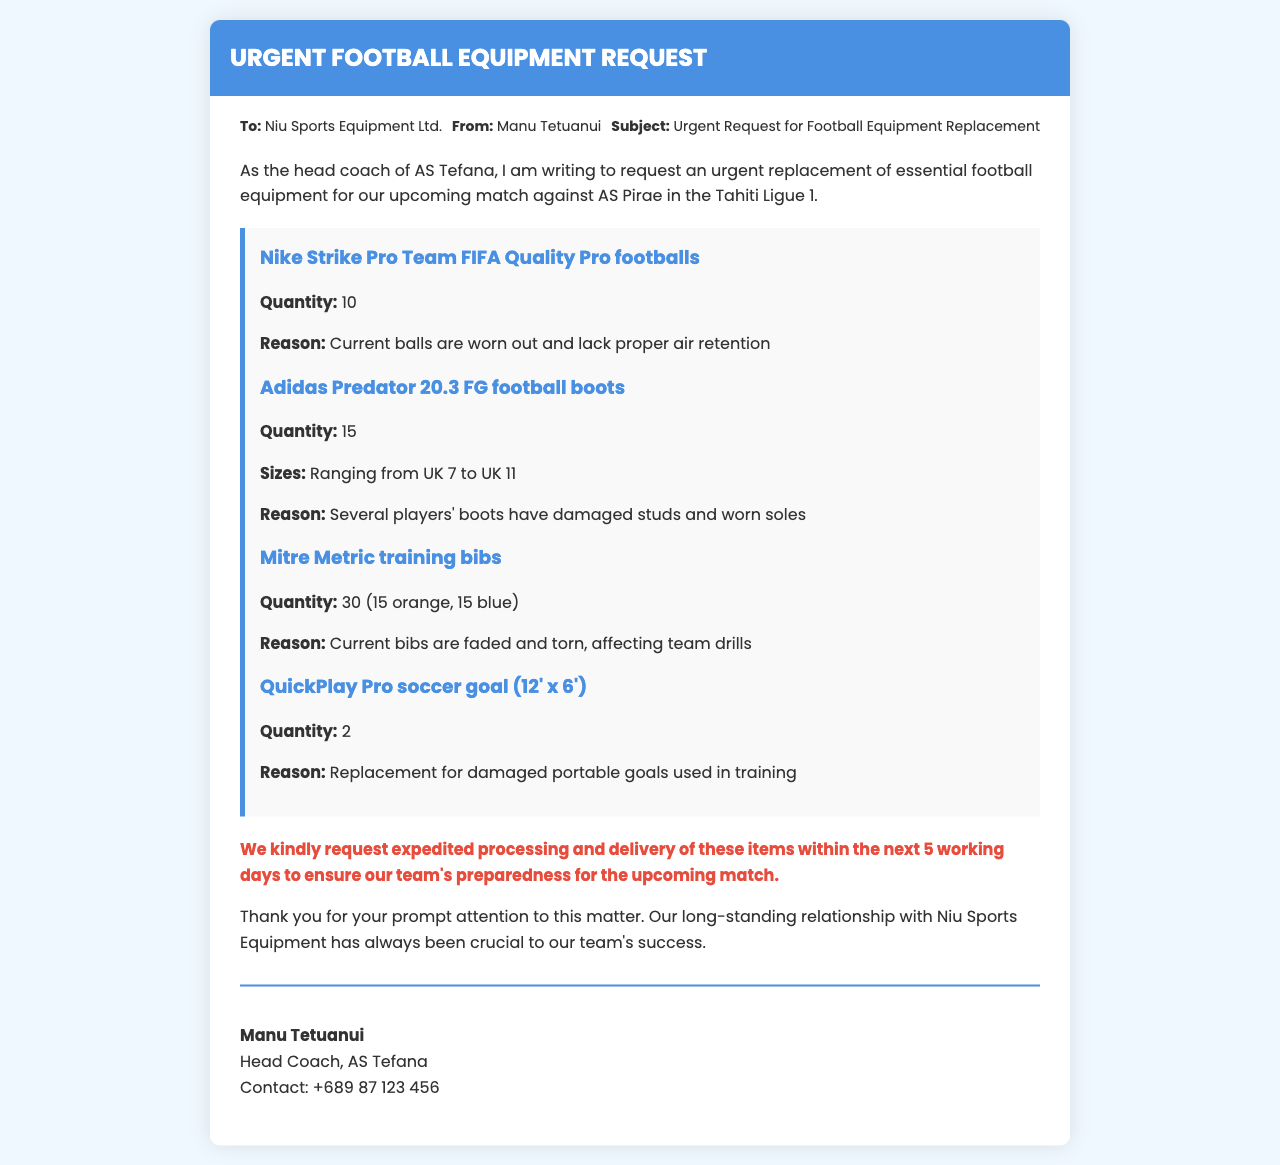what is the subject of the fax? The subject is mentioned in the meta section of the fax and is "Urgent Request for Football Equipment Replacement."
Answer: Urgent Request for Football Equipment Replacement who is the sender of the document? The sender's name is provided in the meta section, which states "From: Manu Tetuanui."
Answer: Manu Tetuanui how many footballs are being requested? The quantity of footballs needed is specified in the equipment list as "10."
Answer: 10 what is the reason for requesting new training bibs? The document states the reason in relation to the bibs: "Current bibs are faded and torn, affecting team drills."
Answer: Faded and torn what contact information is provided for the sender? The sender's contact information is included in the signature section with the phrase "Contact: +689 87 123 456."
Answer: +689 87 123 456 how many sizes of football boots are specified in the document? The document lists sizes of football boots ranging from UK 7 to UK 11, specifying a total of "5" sizes.
Answer: 5 what urgency is stated for processing the request? The urgency is highlighted in the document, indicating the need for items within "the next 5 working days."
Answer: 5 working days how many original pairs of portable goals are mentioned as damaged? The document indicates that "2" portable goals are being requested as replacements for those that are damaged.
Answer: 2 which company is being addressed in the fax? The company to which the fax is addressed is stated in the meta section as "Niu Sports Equipment Ltd."
Answer: Niu Sports Equipment Ltd 